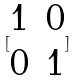Convert formula to latex. <formula><loc_0><loc_0><loc_500><loc_500>[ \begin{matrix} 1 & 0 \\ 0 & 1 \end{matrix} ]</formula> 